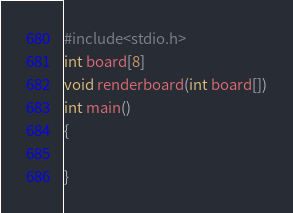<code> <loc_0><loc_0><loc_500><loc_500><_C_>#include<stdio.h>
int board[8]
void renderboard(int board[])
int main()
{
	
}
</code> 